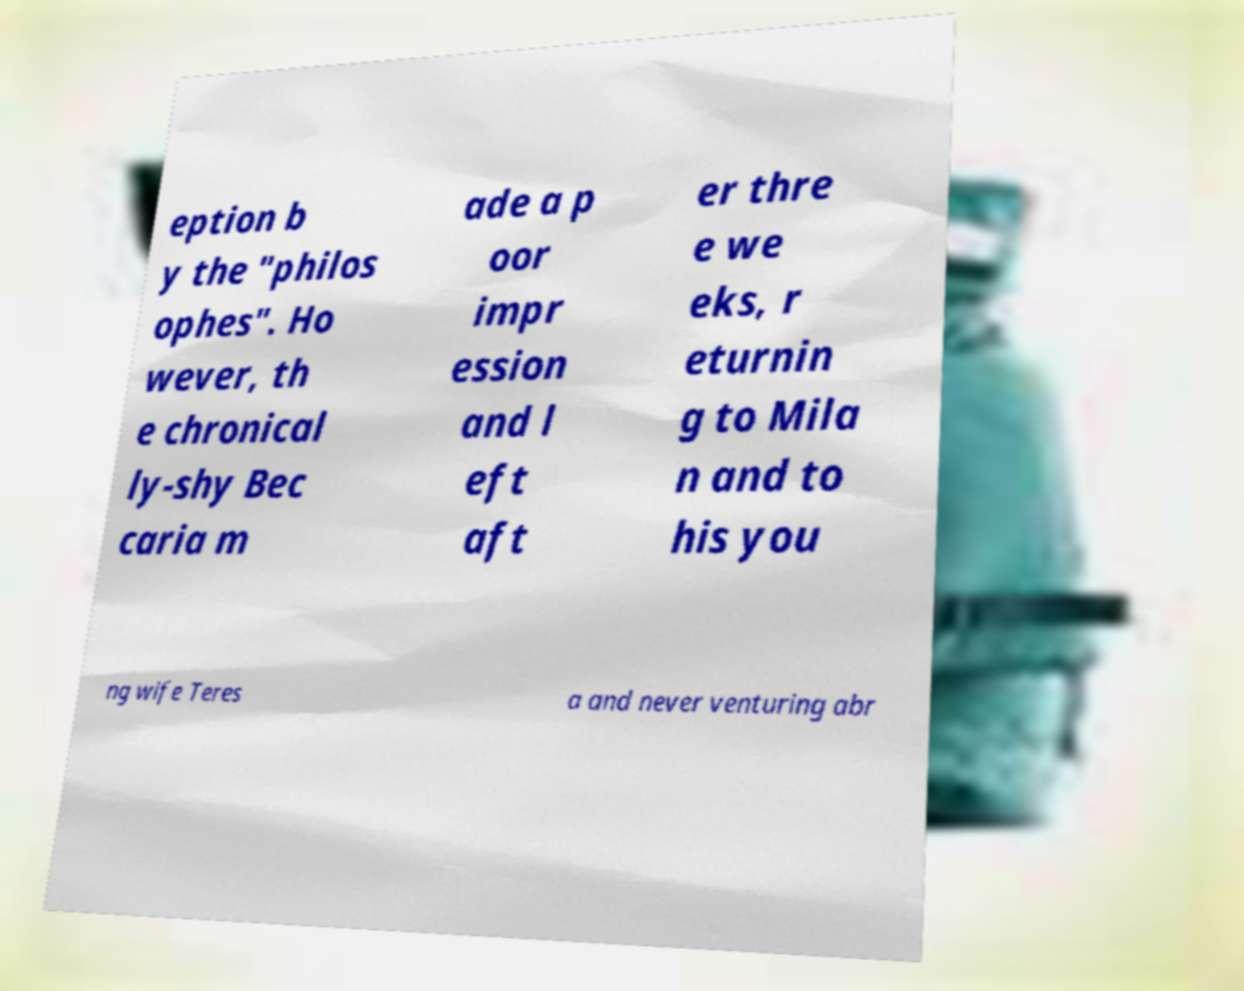Please identify and transcribe the text found in this image. eption b y the "philos ophes". Ho wever, th e chronical ly-shy Bec caria m ade a p oor impr ession and l eft aft er thre e we eks, r eturnin g to Mila n and to his you ng wife Teres a and never venturing abr 